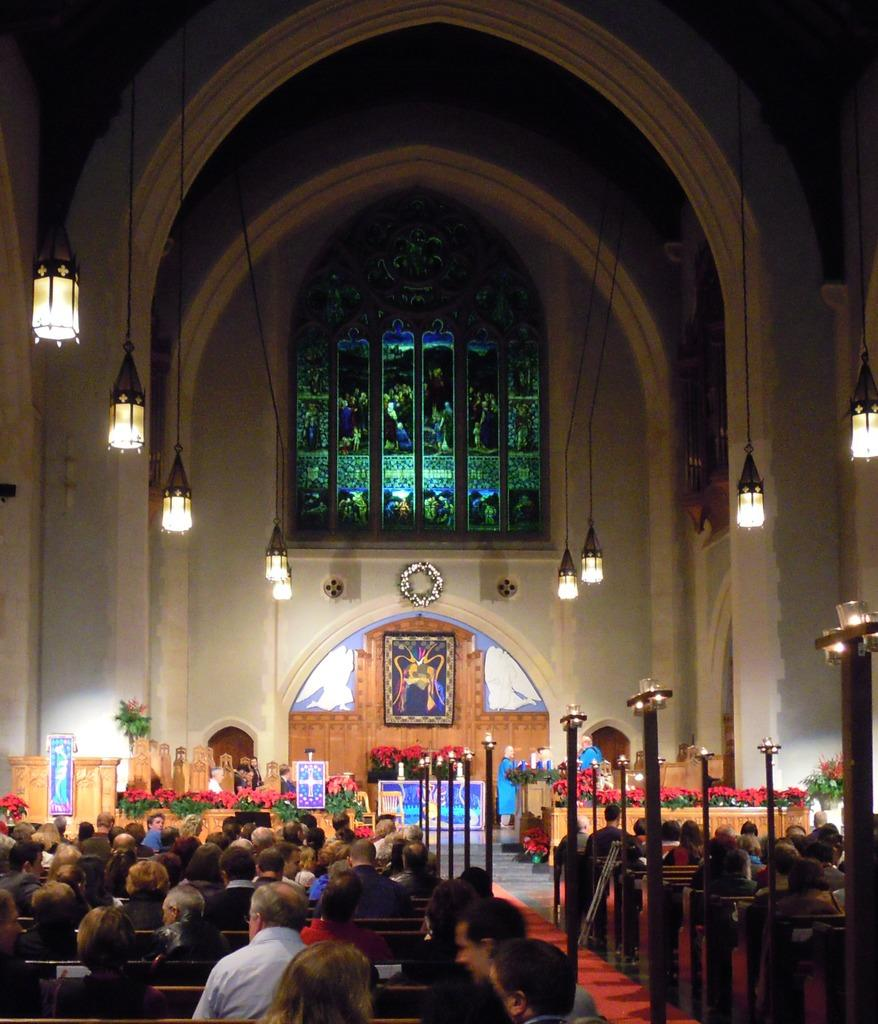What is happening in the front of the image? There are people sitting in the front of the image. What can be seen in the middle of the image? There are lights in the middle of the image. What type of natural elements are visible in the background of the image? There are flowers in the background of the image. What object is present in the background of the image? There is a photo frame in the background of the image. What month is it in the image? The month cannot be determined from the image, as it does not contain any information about the time of year. --- Facts: 1. There is a car in the image. 2. The car is parked on the street. 3. There are trees on the side of the street. 4. The sky is visible in the image. Absurd Topics: bird, ocean, mountain Conversation: What is the main subject of the image? The main subject of the image is a car. Where is the car located in the image? The car is parked on the street. What type of natural elements can be seen on the side of the street? There are trees on the side of the street. What is visible in the background of the image? The sky is visible in the image. Reasoning: Let's think step by step in order to produce the conversation. We start by identifying the main subject of the image, which is the car. Then, we expand the conversation to include other items that are also visible, such as the street, trees, and the sky. Each question is designed to elicit a specific detail about the image that is known from the provided facts. Absurd Question/Answer: Can you see any mountains in the image? No, there are no mountains visible in the image. 